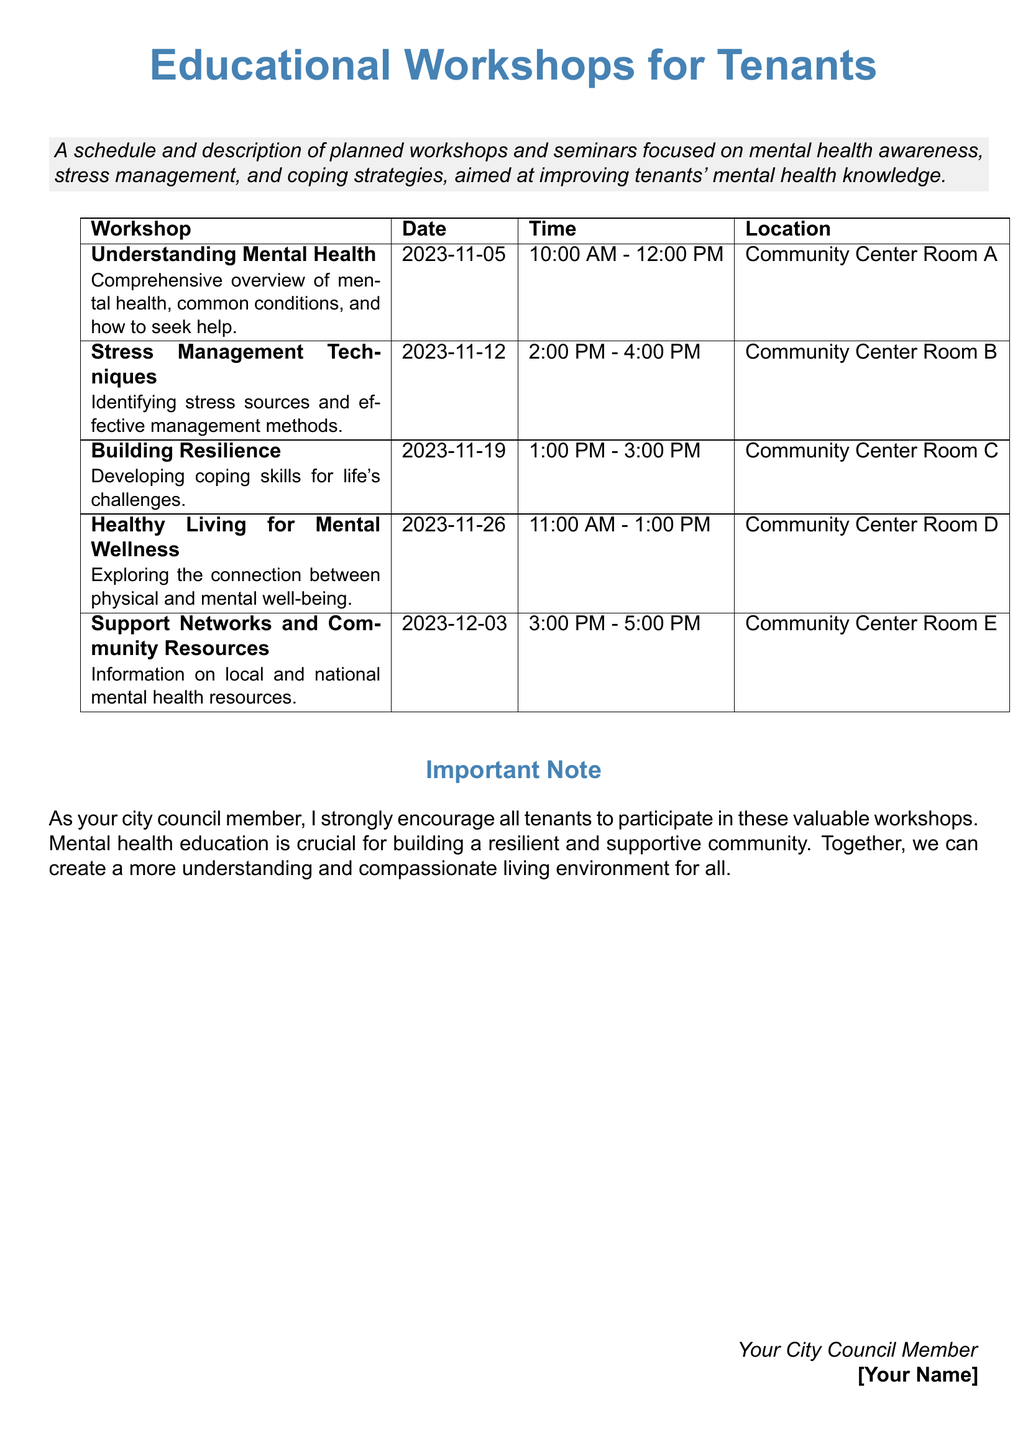What is the title of the document? The title provides a clear identification of the focus of the workshops outlined in the document.
Answer: Educational Workshops for Tenants How many workshops are planned? The number of workshops is determined by counting the entries in the table provided in the document.
Answer: 5 What is the date of the "Stress Management Techniques" workshop? This information is found in the schedule section of the document, specifically under the workshop name's corresponding date.
Answer: 2023-11-12 Which room will "Understanding Mental Health" be held in? The location for the workshop is detailed in the provided table, indicating where it will take place.
Answer: Community Center Room A What time does the "Building Resilience" workshop start? The start time for the workshops is listed in the schedule, associated with the workshop title.
Answer: 1:00 PM Why is participation in these workshops encouraged? The document contains a statement emphasizing the importance of mental health education for the community, giving a rationale for participation.
Answer: Building a resilient and supportive community What is the focus of the "Healthy Living for Mental Wellness" workshop? This information is available as a brief description next to the workshop title in the table.
Answer: The connection between physical and mental well-being What type of resources will be discussed in the last workshop? The description next to the workshop name indicates the nature of the resources to be provided.
Answer: Mental health resources What is the main objective of the workshops? The objective of the workshops is stated in the introductory section of the document.
Answer: Improving tenants' mental health knowledge 